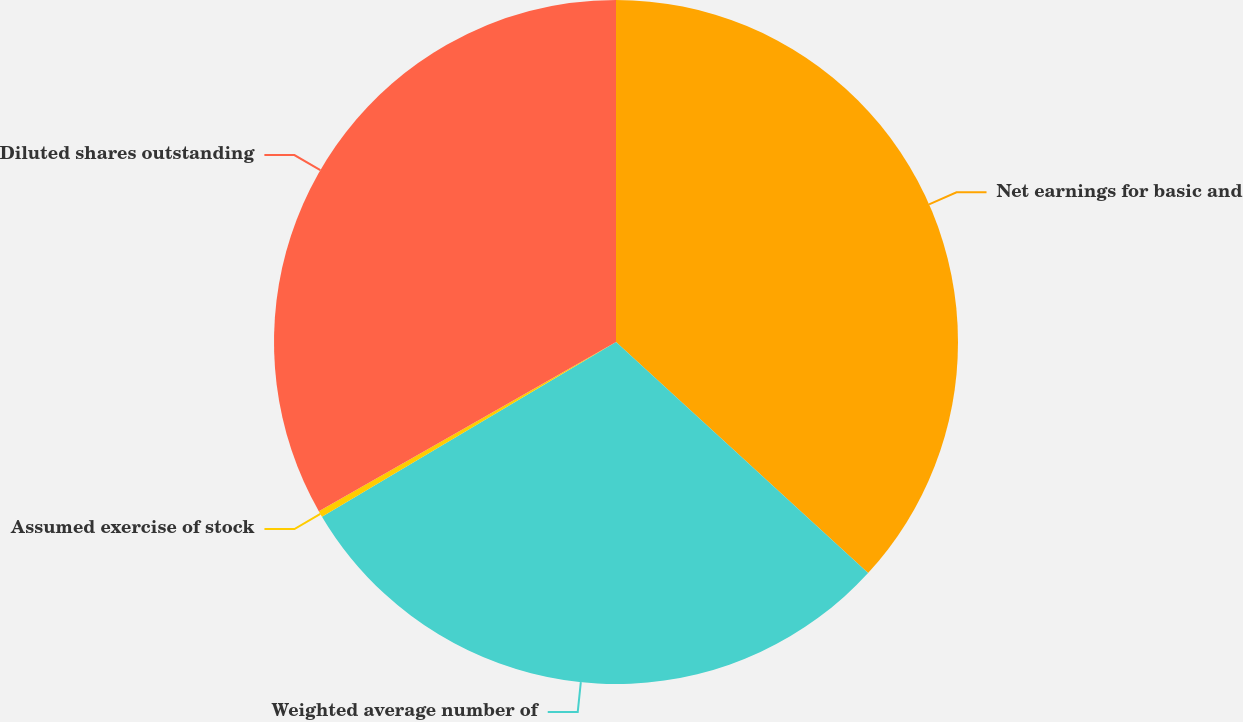Convert chart. <chart><loc_0><loc_0><loc_500><loc_500><pie_chart><fcel>Net earnings for basic and<fcel>Weighted average number of<fcel>Assumed exercise of stock<fcel>Diluted shares outstanding<nl><fcel>36.81%<fcel>29.66%<fcel>0.29%<fcel>33.24%<nl></chart> 